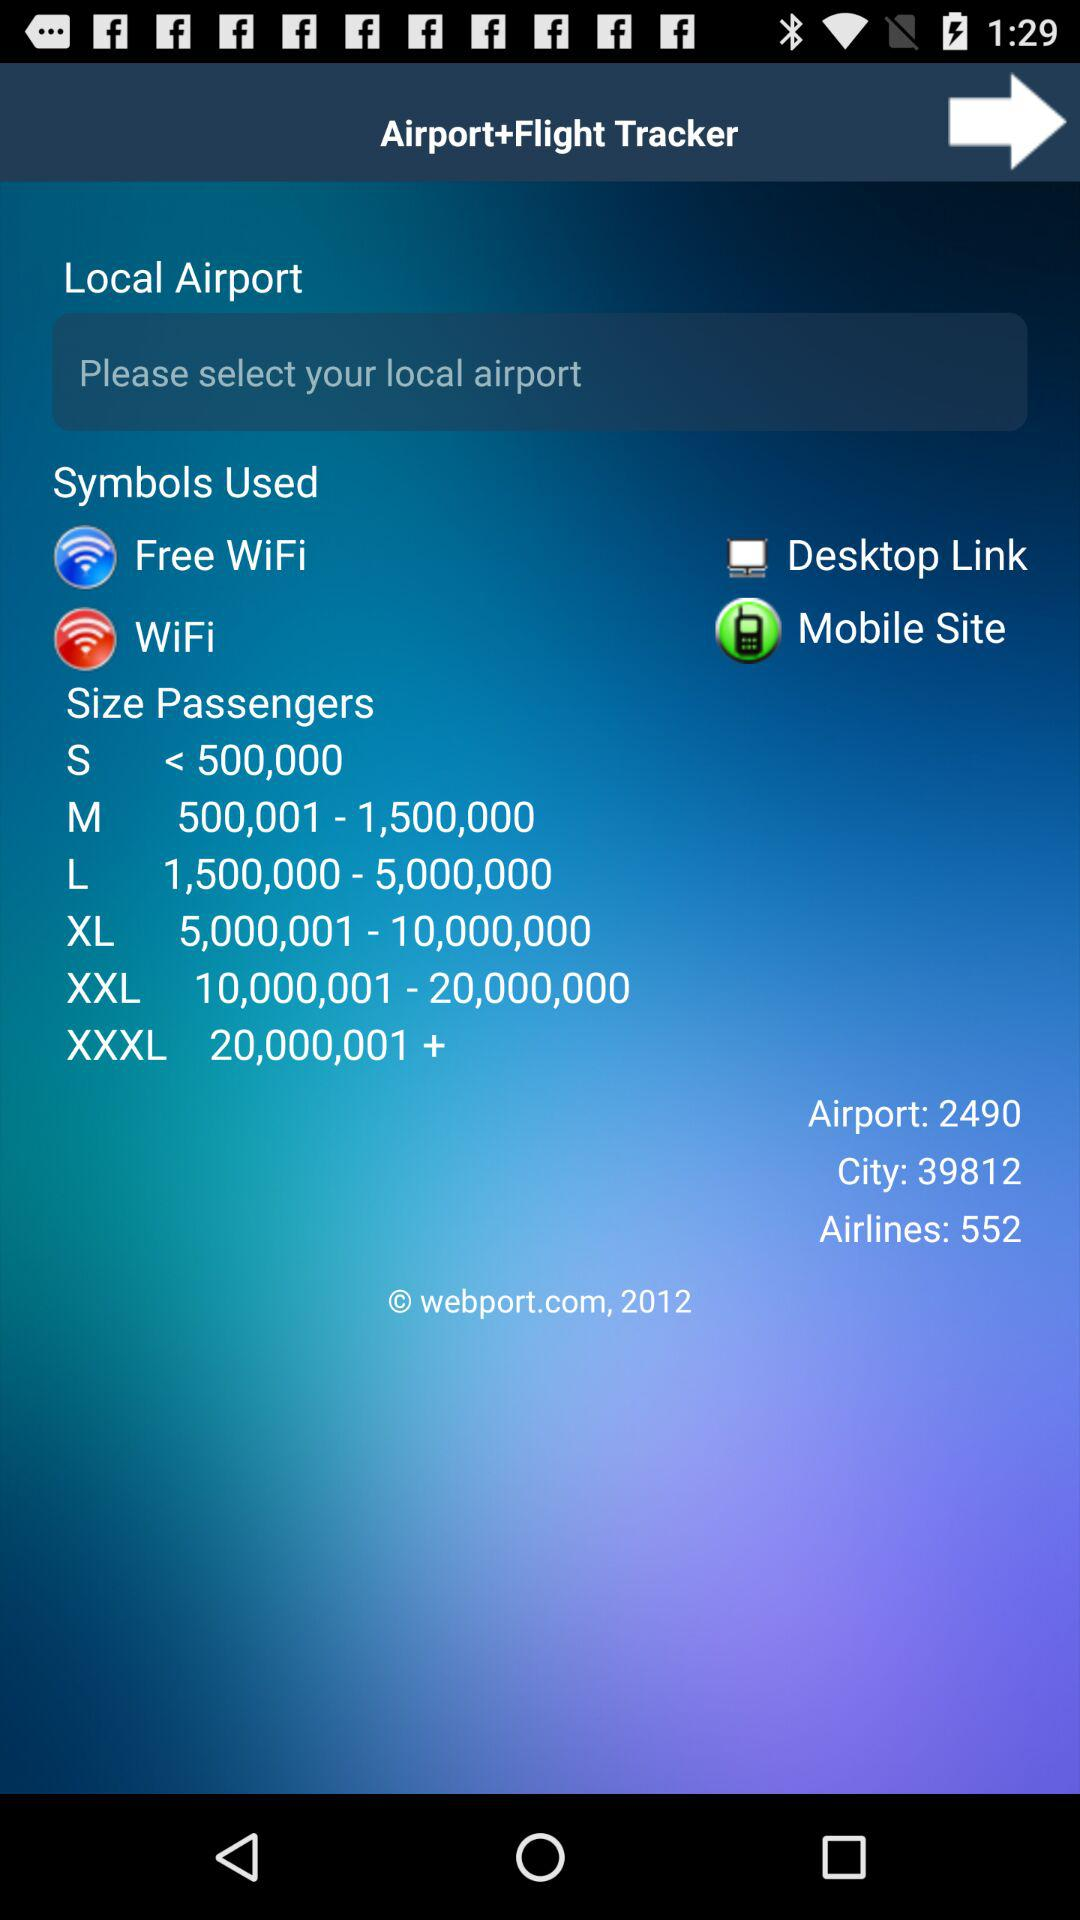How many cities in total are there? There are 39812 cities in total. 